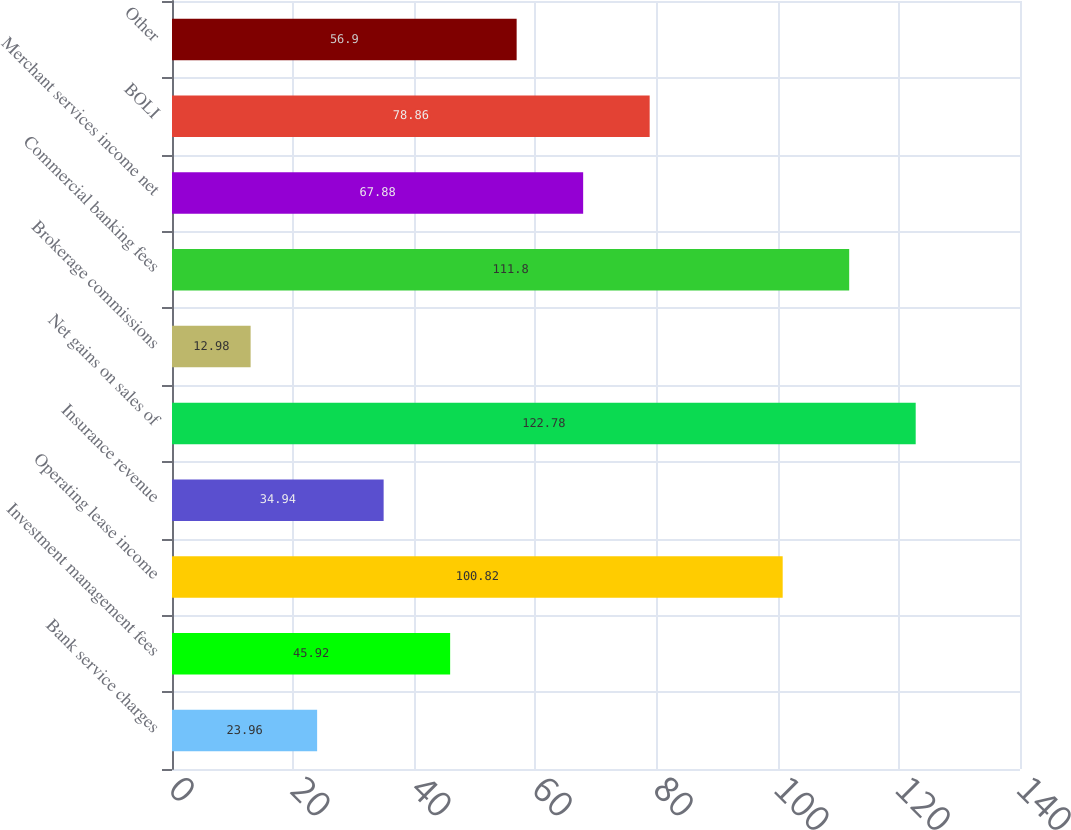Convert chart. <chart><loc_0><loc_0><loc_500><loc_500><bar_chart><fcel>Bank service charges<fcel>Investment management fees<fcel>Operating lease income<fcel>Insurance revenue<fcel>Net gains on sales of<fcel>Brokerage commissions<fcel>Commercial banking fees<fcel>Merchant services income net<fcel>BOLI<fcel>Other<nl><fcel>23.96<fcel>45.92<fcel>100.82<fcel>34.94<fcel>122.78<fcel>12.98<fcel>111.8<fcel>67.88<fcel>78.86<fcel>56.9<nl></chart> 